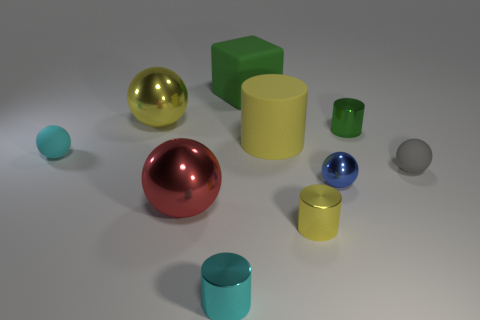Is the number of big green things that are in front of the large red sphere less than the number of green cubes? Upon closer inspection of the image, the number of large green objects in front of the large red sphere is indeed less than the overall count of green cubes present. 